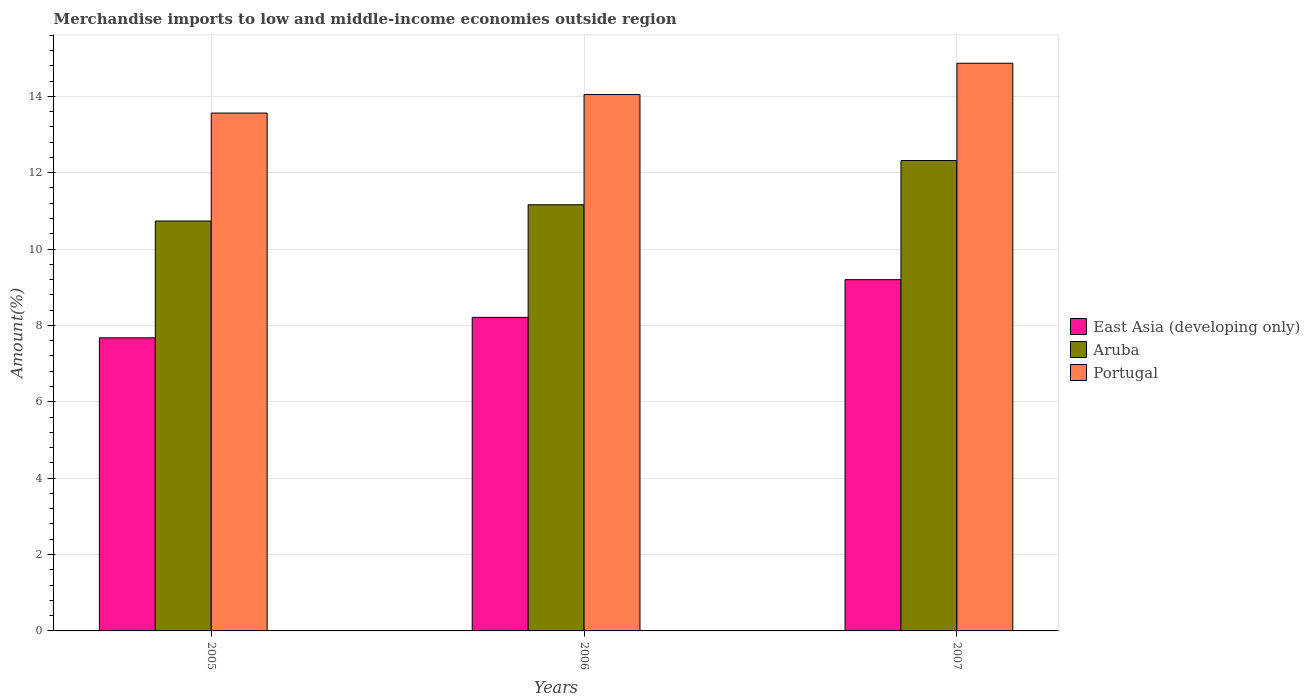How many different coloured bars are there?
Your answer should be very brief. 3. How many groups of bars are there?
Your response must be concise. 3. Are the number of bars per tick equal to the number of legend labels?
Ensure brevity in your answer.  Yes. Are the number of bars on each tick of the X-axis equal?
Provide a short and direct response. Yes. How many bars are there on the 1st tick from the right?
Your answer should be compact. 3. In how many cases, is the number of bars for a given year not equal to the number of legend labels?
Your answer should be very brief. 0. What is the percentage of amount earned from merchandise imports in East Asia (developing only) in 2007?
Give a very brief answer. 9.2. Across all years, what is the maximum percentage of amount earned from merchandise imports in Aruba?
Keep it short and to the point. 12.32. Across all years, what is the minimum percentage of amount earned from merchandise imports in Portugal?
Your answer should be very brief. 13.56. In which year was the percentage of amount earned from merchandise imports in Aruba maximum?
Ensure brevity in your answer.  2007. What is the total percentage of amount earned from merchandise imports in East Asia (developing only) in the graph?
Your answer should be compact. 25.08. What is the difference between the percentage of amount earned from merchandise imports in East Asia (developing only) in 2005 and that in 2007?
Offer a terse response. -1.52. What is the difference between the percentage of amount earned from merchandise imports in Portugal in 2005 and the percentage of amount earned from merchandise imports in Aruba in 2006?
Provide a succinct answer. 2.4. What is the average percentage of amount earned from merchandise imports in Portugal per year?
Your answer should be very brief. 14.16. In the year 2005, what is the difference between the percentage of amount earned from merchandise imports in East Asia (developing only) and percentage of amount earned from merchandise imports in Aruba?
Your answer should be very brief. -3.06. What is the ratio of the percentage of amount earned from merchandise imports in East Asia (developing only) in 2006 to that in 2007?
Make the answer very short. 0.89. What is the difference between the highest and the second highest percentage of amount earned from merchandise imports in East Asia (developing only)?
Offer a very short reply. 0.99. What is the difference between the highest and the lowest percentage of amount earned from merchandise imports in East Asia (developing only)?
Make the answer very short. 1.52. Is the sum of the percentage of amount earned from merchandise imports in East Asia (developing only) in 2005 and 2006 greater than the maximum percentage of amount earned from merchandise imports in Aruba across all years?
Your response must be concise. Yes. What does the 2nd bar from the left in 2007 represents?
Provide a short and direct response. Aruba. How many years are there in the graph?
Your answer should be compact. 3. Are the values on the major ticks of Y-axis written in scientific E-notation?
Offer a very short reply. No. Does the graph contain any zero values?
Keep it short and to the point. No. How are the legend labels stacked?
Make the answer very short. Vertical. What is the title of the graph?
Offer a terse response. Merchandise imports to low and middle-income economies outside region. What is the label or title of the X-axis?
Give a very brief answer. Years. What is the label or title of the Y-axis?
Offer a terse response. Amount(%). What is the Amount(%) of East Asia (developing only) in 2005?
Offer a terse response. 7.68. What is the Amount(%) of Aruba in 2005?
Offer a terse response. 10.73. What is the Amount(%) in Portugal in 2005?
Keep it short and to the point. 13.56. What is the Amount(%) of East Asia (developing only) in 2006?
Your response must be concise. 8.21. What is the Amount(%) of Aruba in 2006?
Your response must be concise. 11.16. What is the Amount(%) of Portugal in 2006?
Your response must be concise. 14.05. What is the Amount(%) in East Asia (developing only) in 2007?
Make the answer very short. 9.2. What is the Amount(%) in Aruba in 2007?
Your response must be concise. 12.32. What is the Amount(%) of Portugal in 2007?
Provide a succinct answer. 14.87. Across all years, what is the maximum Amount(%) of East Asia (developing only)?
Your response must be concise. 9.2. Across all years, what is the maximum Amount(%) of Aruba?
Provide a short and direct response. 12.32. Across all years, what is the maximum Amount(%) in Portugal?
Offer a terse response. 14.87. Across all years, what is the minimum Amount(%) of East Asia (developing only)?
Keep it short and to the point. 7.68. Across all years, what is the minimum Amount(%) of Aruba?
Provide a succinct answer. 10.73. Across all years, what is the minimum Amount(%) in Portugal?
Provide a short and direct response. 13.56. What is the total Amount(%) in East Asia (developing only) in the graph?
Your answer should be very brief. 25.08. What is the total Amount(%) in Aruba in the graph?
Keep it short and to the point. 34.21. What is the total Amount(%) in Portugal in the graph?
Give a very brief answer. 42.47. What is the difference between the Amount(%) of East Asia (developing only) in 2005 and that in 2006?
Keep it short and to the point. -0.54. What is the difference between the Amount(%) in Aruba in 2005 and that in 2006?
Offer a very short reply. -0.43. What is the difference between the Amount(%) of Portugal in 2005 and that in 2006?
Provide a short and direct response. -0.49. What is the difference between the Amount(%) in East Asia (developing only) in 2005 and that in 2007?
Your answer should be compact. -1.52. What is the difference between the Amount(%) of Aruba in 2005 and that in 2007?
Give a very brief answer. -1.58. What is the difference between the Amount(%) of Portugal in 2005 and that in 2007?
Your answer should be very brief. -1.3. What is the difference between the Amount(%) in East Asia (developing only) in 2006 and that in 2007?
Keep it short and to the point. -0.99. What is the difference between the Amount(%) of Aruba in 2006 and that in 2007?
Keep it short and to the point. -1.16. What is the difference between the Amount(%) in Portugal in 2006 and that in 2007?
Your answer should be very brief. -0.82. What is the difference between the Amount(%) in East Asia (developing only) in 2005 and the Amount(%) in Aruba in 2006?
Offer a very short reply. -3.48. What is the difference between the Amount(%) of East Asia (developing only) in 2005 and the Amount(%) of Portugal in 2006?
Keep it short and to the point. -6.37. What is the difference between the Amount(%) of Aruba in 2005 and the Amount(%) of Portugal in 2006?
Keep it short and to the point. -3.31. What is the difference between the Amount(%) in East Asia (developing only) in 2005 and the Amount(%) in Aruba in 2007?
Your answer should be very brief. -4.64. What is the difference between the Amount(%) in East Asia (developing only) in 2005 and the Amount(%) in Portugal in 2007?
Your response must be concise. -7.19. What is the difference between the Amount(%) of Aruba in 2005 and the Amount(%) of Portugal in 2007?
Provide a short and direct response. -4.13. What is the difference between the Amount(%) of East Asia (developing only) in 2006 and the Amount(%) of Aruba in 2007?
Keep it short and to the point. -4.11. What is the difference between the Amount(%) in East Asia (developing only) in 2006 and the Amount(%) in Portugal in 2007?
Ensure brevity in your answer.  -6.65. What is the difference between the Amount(%) in Aruba in 2006 and the Amount(%) in Portugal in 2007?
Give a very brief answer. -3.71. What is the average Amount(%) of East Asia (developing only) per year?
Provide a succinct answer. 8.36. What is the average Amount(%) of Aruba per year?
Your answer should be very brief. 11.4. What is the average Amount(%) of Portugal per year?
Offer a very short reply. 14.16. In the year 2005, what is the difference between the Amount(%) in East Asia (developing only) and Amount(%) in Aruba?
Provide a short and direct response. -3.06. In the year 2005, what is the difference between the Amount(%) of East Asia (developing only) and Amount(%) of Portugal?
Make the answer very short. -5.89. In the year 2005, what is the difference between the Amount(%) in Aruba and Amount(%) in Portugal?
Keep it short and to the point. -2.83. In the year 2006, what is the difference between the Amount(%) of East Asia (developing only) and Amount(%) of Aruba?
Ensure brevity in your answer.  -2.95. In the year 2006, what is the difference between the Amount(%) in East Asia (developing only) and Amount(%) in Portugal?
Give a very brief answer. -5.84. In the year 2006, what is the difference between the Amount(%) of Aruba and Amount(%) of Portugal?
Offer a terse response. -2.89. In the year 2007, what is the difference between the Amount(%) of East Asia (developing only) and Amount(%) of Aruba?
Your response must be concise. -3.12. In the year 2007, what is the difference between the Amount(%) in East Asia (developing only) and Amount(%) in Portugal?
Your answer should be compact. -5.67. In the year 2007, what is the difference between the Amount(%) of Aruba and Amount(%) of Portugal?
Ensure brevity in your answer.  -2.55. What is the ratio of the Amount(%) in East Asia (developing only) in 2005 to that in 2006?
Offer a terse response. 0.93. What is the ratio of the Amount(%) of Aruba in 2005 to that in 2006?
Provide a succinct answer. 0.96. What is the ratio of the Amount(%) of Portugal in 2005 to that in 2006?
Your response must be concise. 0.97. What is the ratio of the Amount(%) of East Asia (developing only) in 2005 to that in 2007?
Keep it short and to the point. 0.83. What is the ratio of the Amount(%) of Aruba in 2005 to that in 2007?
Provide a succinct answer. 0.87. What is the ratio of the Amount(%) of Portugal in 2005 to that in 2007?
Your response must be concise. 0.91. What is the ratio of the Amount(%) of East Asia (developing only) in 2006 to that in 2007?
Give a very brief answer. 0.89. What is the ratio of the Amount(%) in Aruba in 2006 to that in 2007?
Your answer should be compact. 0.91. What is the ratio of the Amount(%) of Portugal in 2006 to that in 2007?
Offer a terse response. 0.94. What is the difference between the highest and the second highest Amount(%) in East Asia (developing only)?
Make the answer very short. 0.99. What is the difference between the highest and the second highest Amount(%) in Aruba?
Keep it short and to the point. 1.16. What is the difference between the highest and the second highest Amount(%) in Portugal?
Your answer should be compact. 0.82. What is the difference between the highest and the lowest Amount(%) of East Asia (developing only)?
Ensure brevity in your answer.  1.52. What is the difference between the highest and the lowest Amount(%) of Aruba?
Make the answer very short. 1.58. What is the difference between the highest and the lowest Amount(%) of Portugal?
Keep it short and to the point. 1.3. 